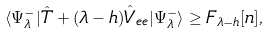Convert formula to latex. <formula><loc_0><loc_0><loc_500><loc_500>\langle \Psi _ { \lambda } ^ { - } | \hat { T } + ( \lambda - h ) \hat { V } _ { e e } | \Psi _ { \lambda } ^ { - } \rangle \geq F _ { \lambda - h } [ n ] ,</formula> 